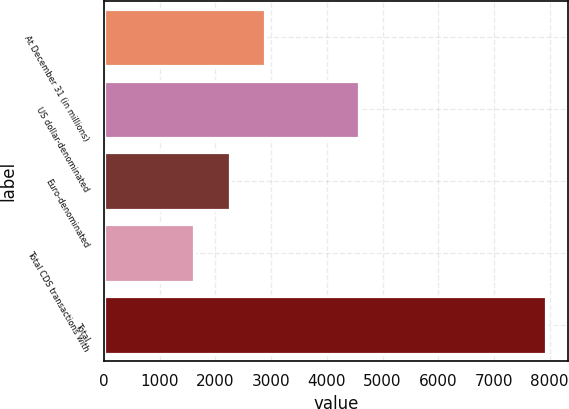<chart> <loc_0><loc_0><loc_500><loc_500><bar_chart><fcel>At December 31 (in millions)<fcel>US dollar-denominated<fcel>Euro-denominated<fcel>Total CDS transactions with<fcel>Total<nl><fcel>2886<fcel>4580<fcel>2256<fcel>1626<fcel>7926<nl></chart> 